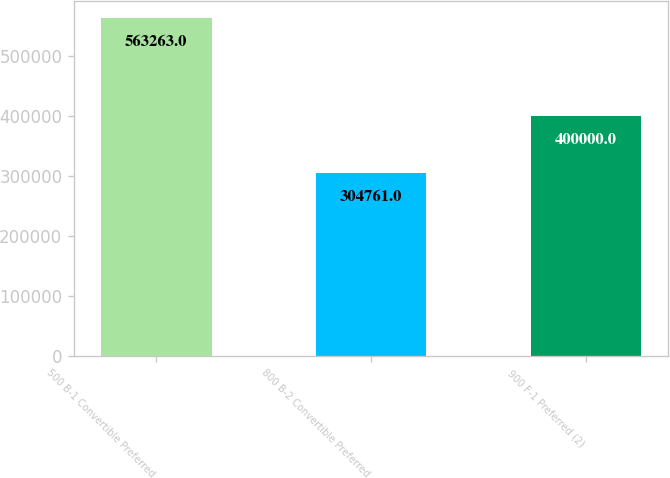<chart> <loc_0><loc_0><loc_500><loc_500><bar_chart><fcel>500 B-1 Convertible Preferred<fcel>800 B-2 Convertible Preferred<fcel>900 F-1 Preferred (2)<nl><fcel>563263<fcel>304761<fcel>400000<nl></chart> 